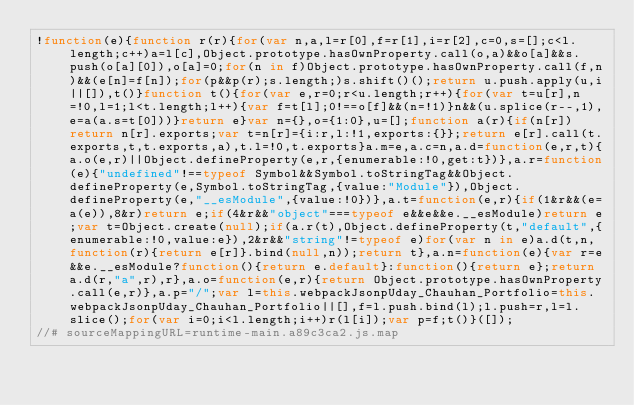<code> <loc_0><loc_0><loc_500><loc_500><_JavaScript_>!function(e){function r(r){for(var n,a,l=r[0],f=r[1],i=r[2],c=0,s=[];c<l.length;c++)a=l[c],Object.prototype.hasOwnProperty.call(o,a)&&o[a]&&s.push(o[a][0]),o[a]=0;for(n in f)Object.prototype.hasOwnProperty.call(f,n)&&(e[n]=f[n]);for(p&&p(r);s.length;)s.shift()();return u.push.apply(u,i||[]),t()}function t(){for(var e,r=0;r<u.length;r++){for(var t=u[r],n=!0,l=1;l<t.length;l++){var f=t[l];0!==o[f]&&(n=!1)}n&&(u.splice(r--,1),e=a(a.s=t[0]))}return e}var n={},o={1:0},u=[];function a(r){if(n[r])return n[r].exports;var t=n[r]={i:r,l:!1,exports:{}};return e[r].call(t.exports,t,t.exports,a),t.l=!0,t.exports}a.m=e,a.c=n,a.d=function(e,r,t){a.o(e,r)||Object.defineProperty(e,r,{enumerable:!0,get:t})},a.r=function(e){"undefined"!==typeof Symbol&&Symbol.toStringTag&&Object.defineProperty(e,Symbol.toStringTag,{value:"Module"}),Object.defineProperty(e,"__esModule",{value:!0})},a.t=function(e,r){if(1&r&&(e=a(e)),8&r)return e;if(4&r&&"object"===typeof e&&e&&e.__esModule)return e;var t=Object.create(null);if(a.r(t),Object.defineProperty(t,"default",{enumerable:!0,value:e}),2&r&&"string"!=typeof e)for(var n in e)a.d(t,n,function(r){return e[r]}.bind(null,n));return t},a.n=function(e){var r=e&&e.__esModule?function(){return e.default}:function(){return e};return a.d(r,"a",r),r},a.o=function(e,r){return Object.prototype.hasOwnProperty.call(e,r)},a.p="/";var l=this.webpackJsonpUday_Chauhan_Portfolio=this.webpackJsonpUday_Chauhan_Portfolio||[],f=l.push.bind(l);l.push=r,l=l.slice();for(var i=0;i<l.length;i++)r(l[i]);var p=f;t()}([]);
//# sourceMappingURL=runtime-main.a89c3ca2.js.map</code> 